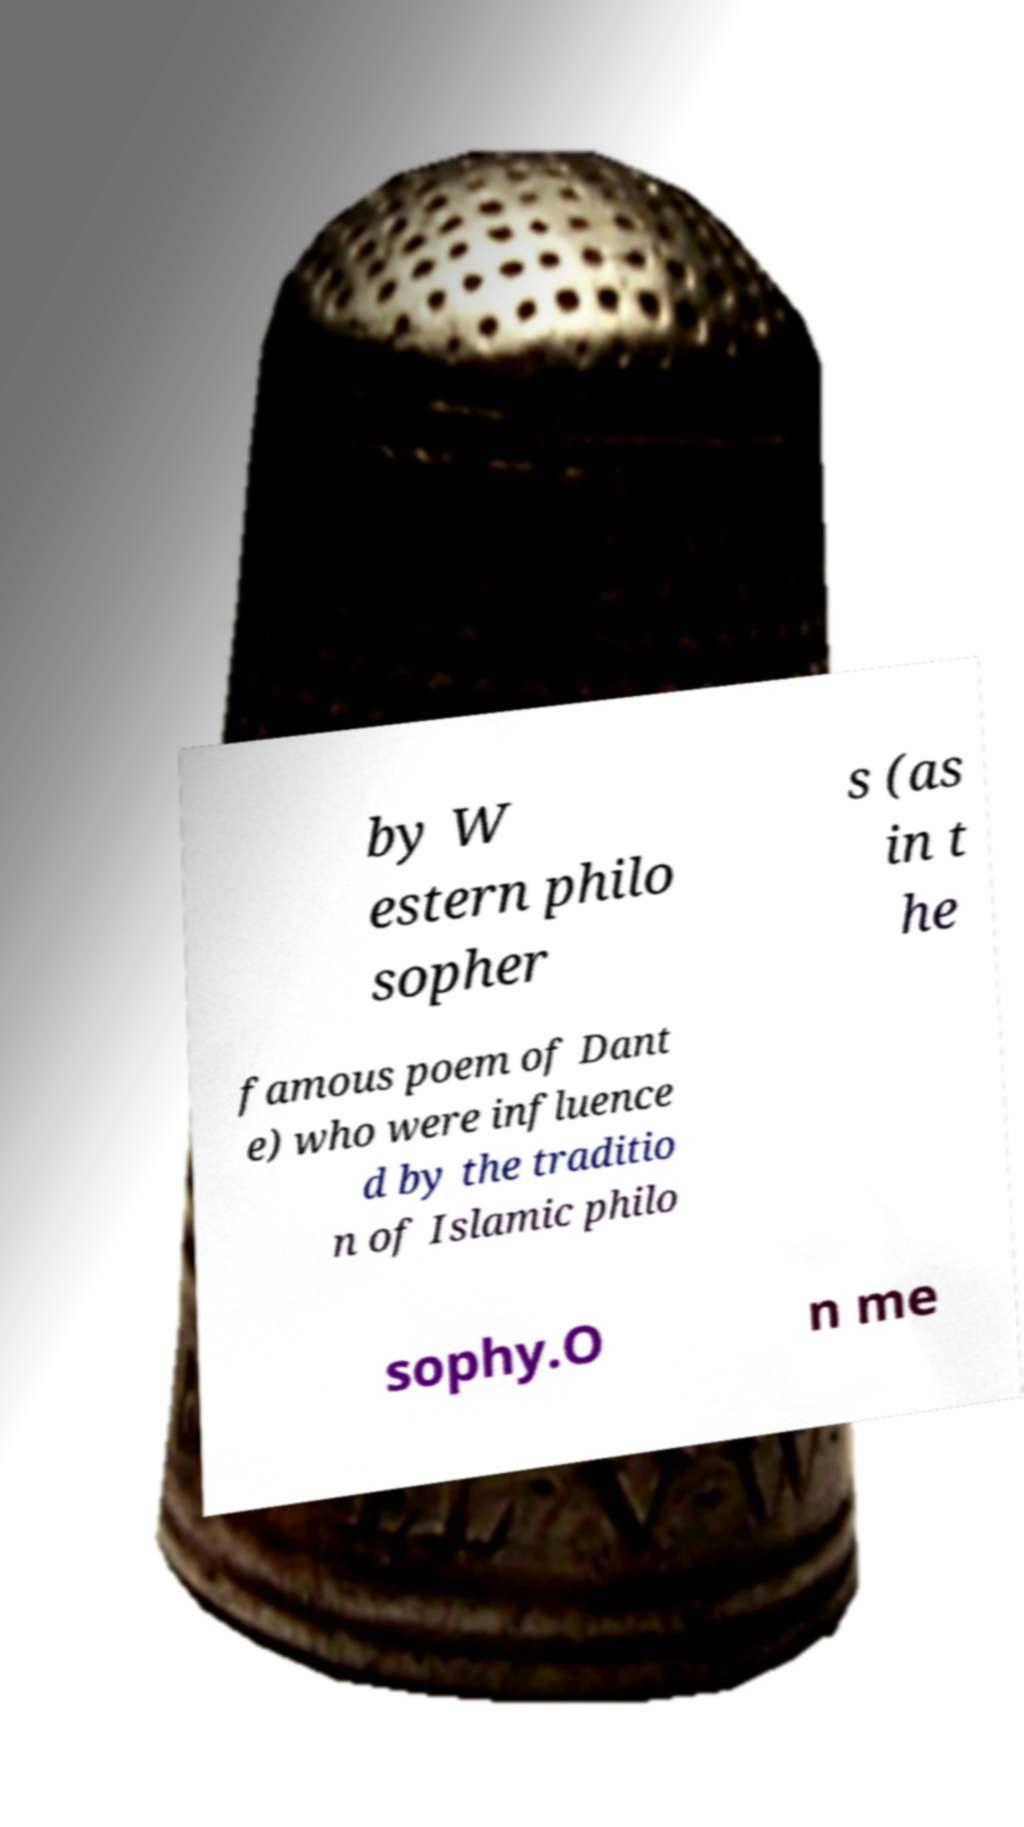Please read and relay the text visible in this image. What does it say? by W estern philo sopher s (as in t he famous poem of Dant e) who were influence d by the traditio n of Islamic philo sophy.O n me 